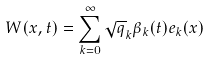Convert formula to latex. <formula><loc_0><loc_0><loc_500><loc_500>W ( x , t ) = \sum _ { k = 0 } ^ { \infty } \sqrt { q } _ { k } \beta _ { k } ( t ) e _ { k } ( x )</formula> 